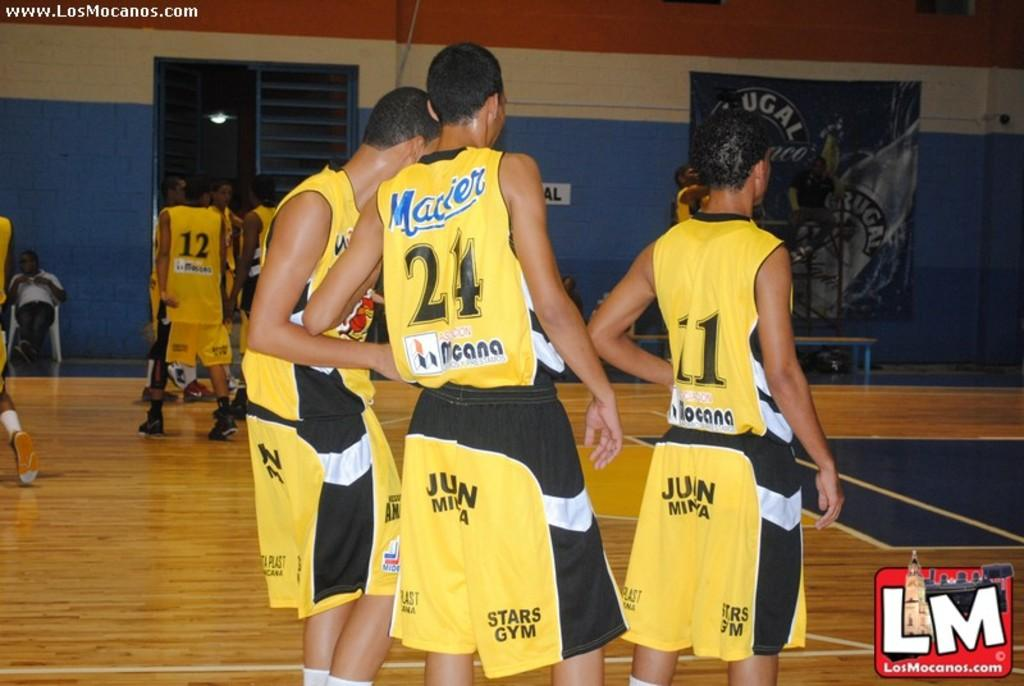Provide a one-sentence caption for the provided image. Stars Gym is printed on the yellow shorts of the players. 